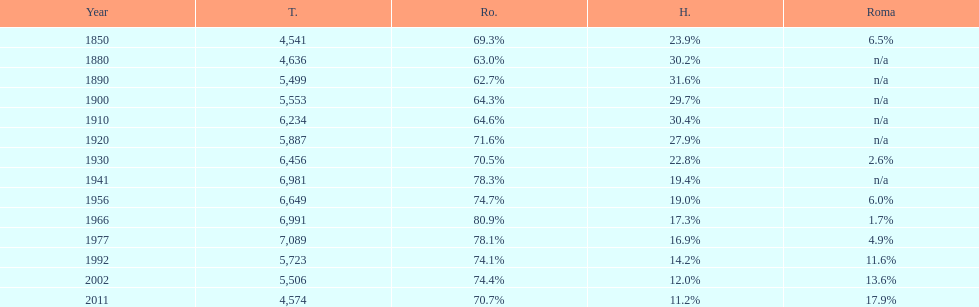What is the number of hungarians in 1850? 23.9%. 